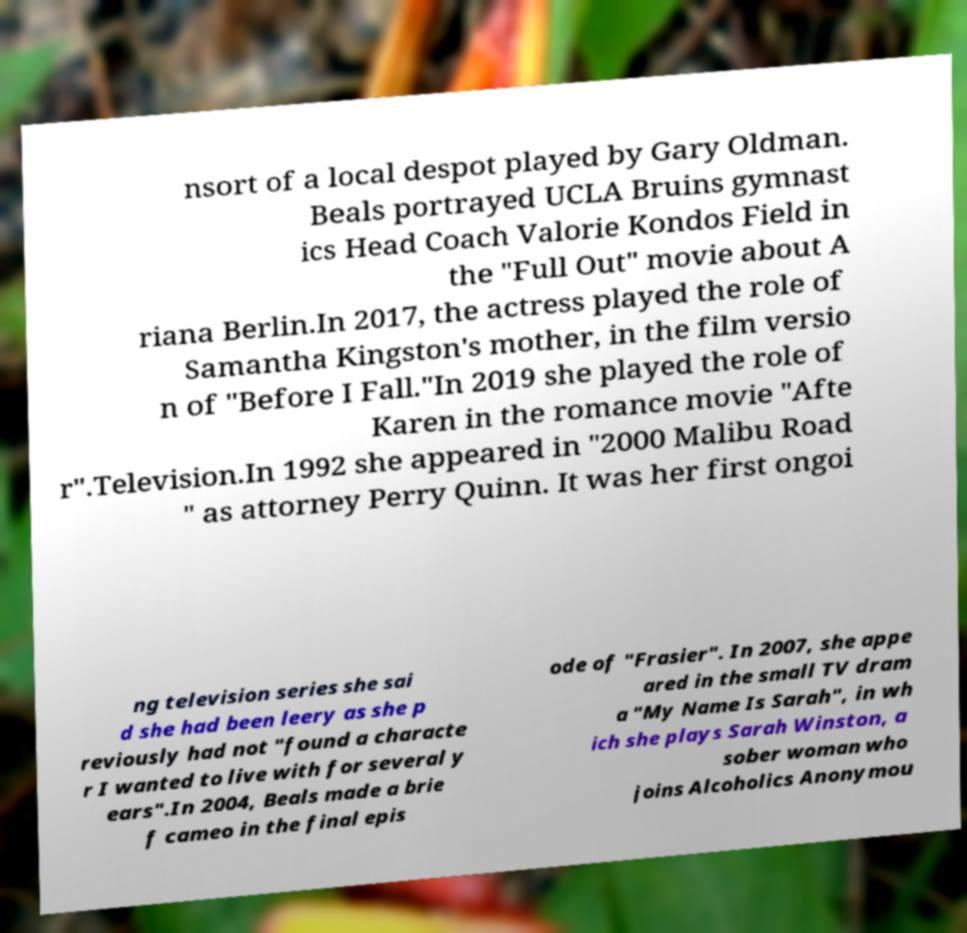What messages or text are displayed in this image? I need them in a readable, typed format. nsort of a local despot played by Gary Oldman. Beals portrayed UCLA Bruins gymnast ics Head Coach Valorie Kondos Field in the "Full Out" movie about A riana Berlin.In 2017, the actress played the role of Samantha Kingston's mother, in the film versio n of "Before I Fall."In 2019 she played the role of Karen in the romance movie "Afte r".Television.In 1992 she appeared in "2000 Malibu Road " as attorney Perry Quinn. It was her first ongoi ng television series she sai d she had been leery as she p reviously had not "found a characte r I wanted to live with for several y ears".In 2004, Beals made a brie f cameo in the final epis ode of "Frasier". In 2007, she appe ared in the small TV dram a "My Name Is Sarah", in wh ich she plays Sarah Winston, a sober woman who joins Alcoholics Anonymou 